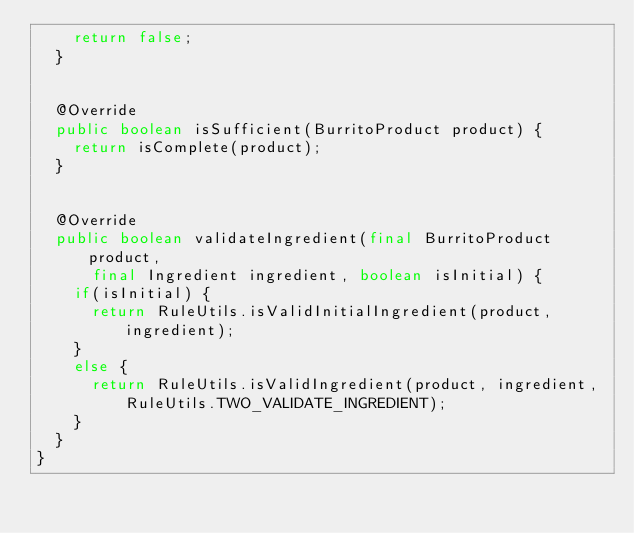Convert code to text. <code><loc_0><loc_0><loc_500><loc_500><_Java_>		return false;
	}


	@Override
	public boolean isSufficient(BurritoProduct product) {
		return isComplete(product);
	}


	@Override
	public boolean validateIngredient(final BurritoProduct product,
			final Ingredient ingredient, boolean isInitial) {
		if(isInitial) {
			return RuleUtils.isValidInitialIngredient(product, ingredient);
		}
		else {
			return RuleUtils.isValidIngredient(product, ingredient, RuleUtils.TWO_VALIDATE_INGREDIENT);
		}
	}
}
</code> 